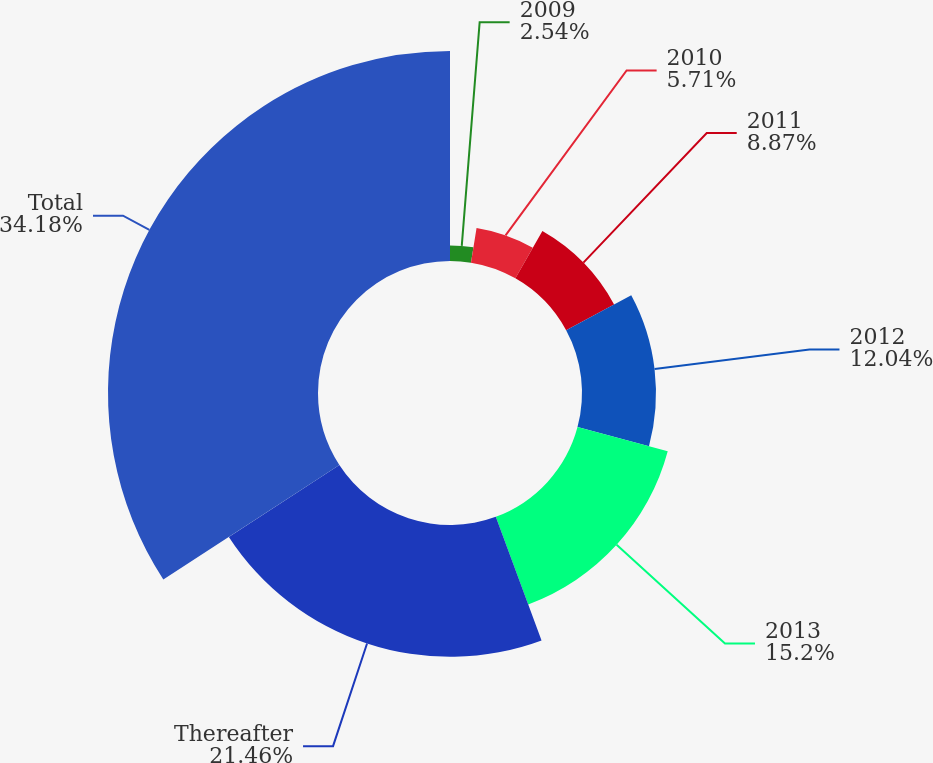<chart> <loc_0><loc_0><loc_500><loc_500><pie_chart><fcel>2009<fcel>2010<fcel>2011<fcel>2012<fcel>2013<fcel>Thereafter<fcel>Total<nl><fcel>2.54%<fcel>5.71%<fcel>8.87%<fcel>12.04%<fcel>15.2%<fcel>21.46%<fcel>34.18%<nl></chart> 